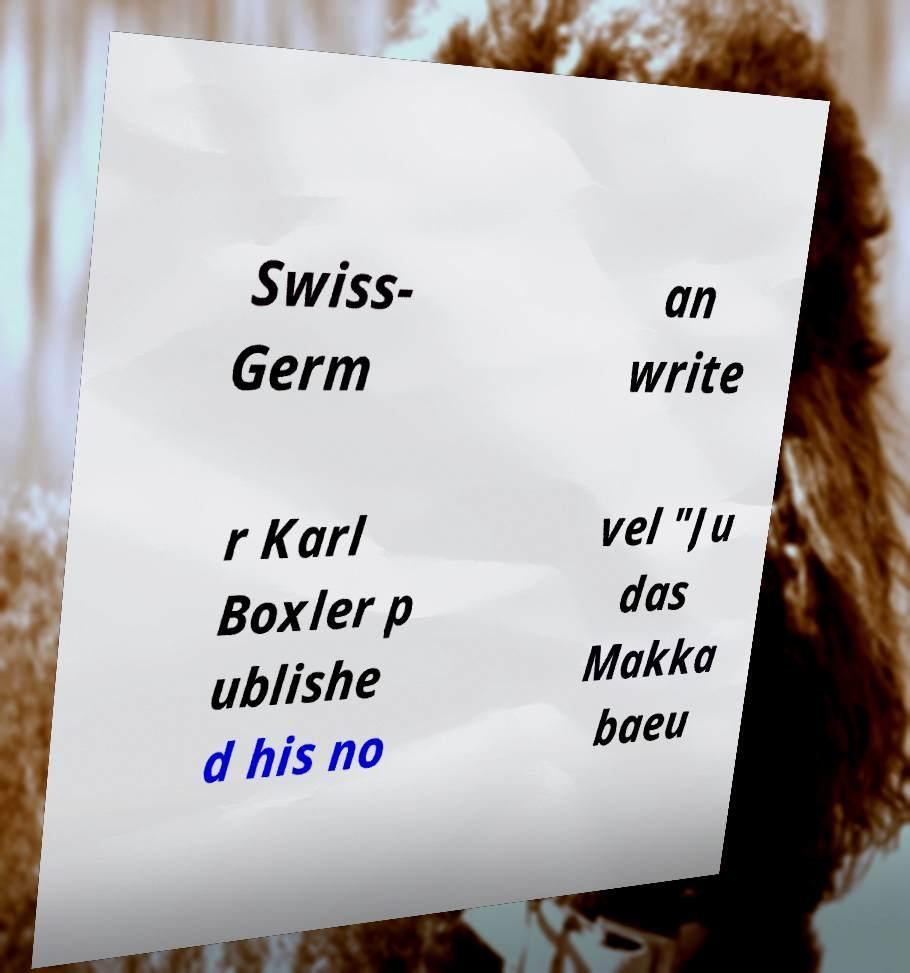Could you assist in decoding the text presented in this image and type it out clearly? Swiss- Germ an write r Karl Boxler p ublishe d his no vel "Ju das Makka baeu 